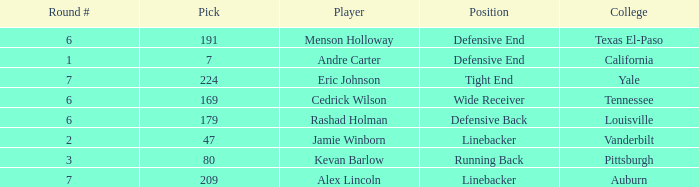Which pick came from Texas El-Paso? 191.0. 